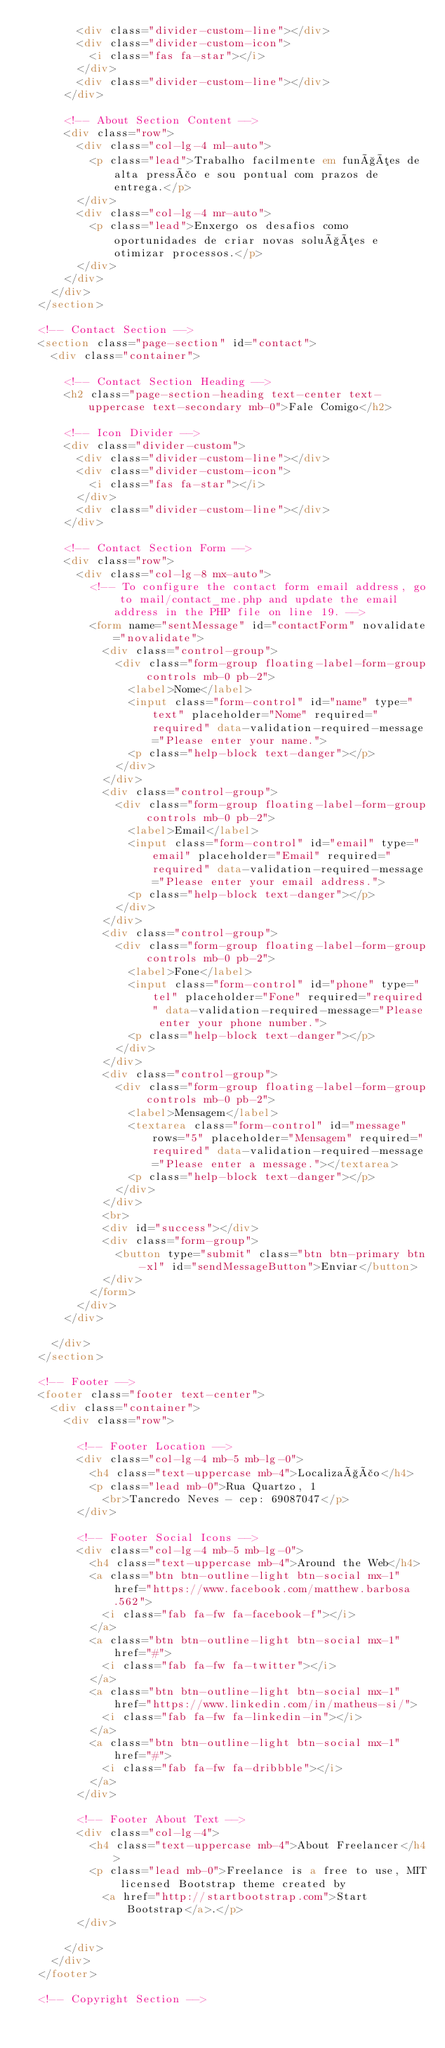Convert code to text. <code><loc_0><loc_0><loc_500><loc_500><_HTML_>        <div class="divider-custom-line"></div>
        <div class="divider-custom-icon">
          <i class="fas fa-star"></i>
        </div>
        <div class="divider-custom-line"></div>
      </div>

      <!-- About Section Content -->
      <div class="row">
        <div class="col-lg-4 ml-auto">
          <p class="lead">Trabalho facilmente em funções de alta pressão e sou pontual com prazos de entrega.</p>
        </div>
        <div class="col-lg-4 mr-auto">
          <p class="lead">Enxergo os desafios como oportunidades de criar novas soluções e otimizar processos.</p>
        </div>
      </div>
    </div>
  </section>

  <!-- Contact Section -->
  <section class="page-section" id="contact">
    <div class="container">

      <!-- Contact Section Heading -->
      <h2 class="page-section-heading text-center text-uppercase text-secondary mb-0">Fale Comigo</h2>

      <!-- Icon Divider -->
      <div class="divider-custom">
        <div class="divider-custom-line"></div>
        <div class="divider-custom-icon">
          <i class="fas fa-star"></i>
        </div>
        <div class="divider-custom-line"></div>
      </div>

      <!-- Contact Section Form -->
      <div class="row">
        <div class="col-lg-8 mx-auto">
          <!-- To configure the contact form email address, go to mail/contact_me.php and update the email address in the PHP file on line 19. -->
          <form name="sentMessage" id="contactForm" novalidate="novalidate">
            <div class="control-group">
              <div class="form-group floating-label-form-group controls mb-0 pb-2">
                <label>Nome</label>
                <input class="form-control" id="name" type="text" placeholder="Nome" required="required" data-validation-required-message="Please enter your name.">
                <p class="help-block text-danger"></p>
              </div>
            </div>
            <div class="control-group">
              <div class="form-group floating-label-form-group controls mb-0 pb-2">
                <label>Email</label>
                <input class="form-control" id="email" type="email" placeholder="Email" required="required" data-validation-required-message="Please enter your email address.">
                <p class="help-block text-danger"></p>
              </div>
            </div>
            <div class="control-group">
              <div class="form-group floating-label-form-group controls mb-0 pb-2">
                <label>Fone</label>
                <input class="form-control" id="phone" type="tel" placeholder="Fone" required="required" data-validation-required-message="Please enter your phone number.">
                <p class="help-block text-danger"></p>
              </div>
            </div>
            <div class="control-group">
              <div class="form-group floating-label-form-group controls mb-0 pb-2">
                <label>Mensagem</label>
                <textarea class="form-control" id="message" rows="5" placeholder="Mensagem" required="required" data-validation-required-message="Please enter a message."></textarea>
                <p class="help-block text-danger"></p>
              </div>
            </div>
            <br>
            <div id="success"></div>
            <div class="form-group">
              <button type="submit" class="btn btn-primary btn-xl" id="sendMessageButton">Enviar</button>
            </div>
          </form>
        </div>
      </div>

    </div>
  </section>

  <!-- Footer -->
  <footer class="footer text-center">
    <div class="container">
      <div class="row">

        <!-- Footer Location -->
        <div class="col-lg-4 mb-5 mb-lg-0">
          <h4 class="text-uppercase mb-4">Localização</h4>
          <p class="lead mb-0">Rua Quartzo, 1
            <br>Tancredo Neves - cep: 69087047</p>
        </div>

        <!-- Footer Social Icons -->
        <div class="col-lg-4 mb-5 mb-lg-0">
          <h4 class="text-uppercase mb-4">Around the Web</h4>
          <a class="btn btn-outline-light btn-social mx-1" href="https://www.facebook.com/matthew.barbosa.562">
            <i class="fab fa-fw fa-facebook-f"></i>
          </a>
          <a class="btn btn-outline-light btn-social mx-1" href="#">
            <i class="fab fa-fw fa-twitter"></i>
          </a>
          <a class="btn btn-outline-light btn-social mx-1" href="https://www.linkedin.com/in/matheus-si/">
            <i class="fab fa-fw fa-linkedin-in"></i>
          </a>
          <a class="btn btn-outline-light btn-social mx-1" href="#">
            <i class="fab fa-fw fa-dribbble"></i>
          </a>
        </div>

        <!-- Footer About Text -->
        <div class="col-lg-4">
          <h4 class="text-uppercase mb-4">About Freelancer</h4>
          <p class="lead mb-0">Freelance is a free to use, MIT licensed Bootstrap theme created by
            <a href="http://startbootstrap.com">Start Bootstrap</a>.</p>
        </div>

      </div>
    </div>
  </footer>

  <!-- Copyright Section --></code> 